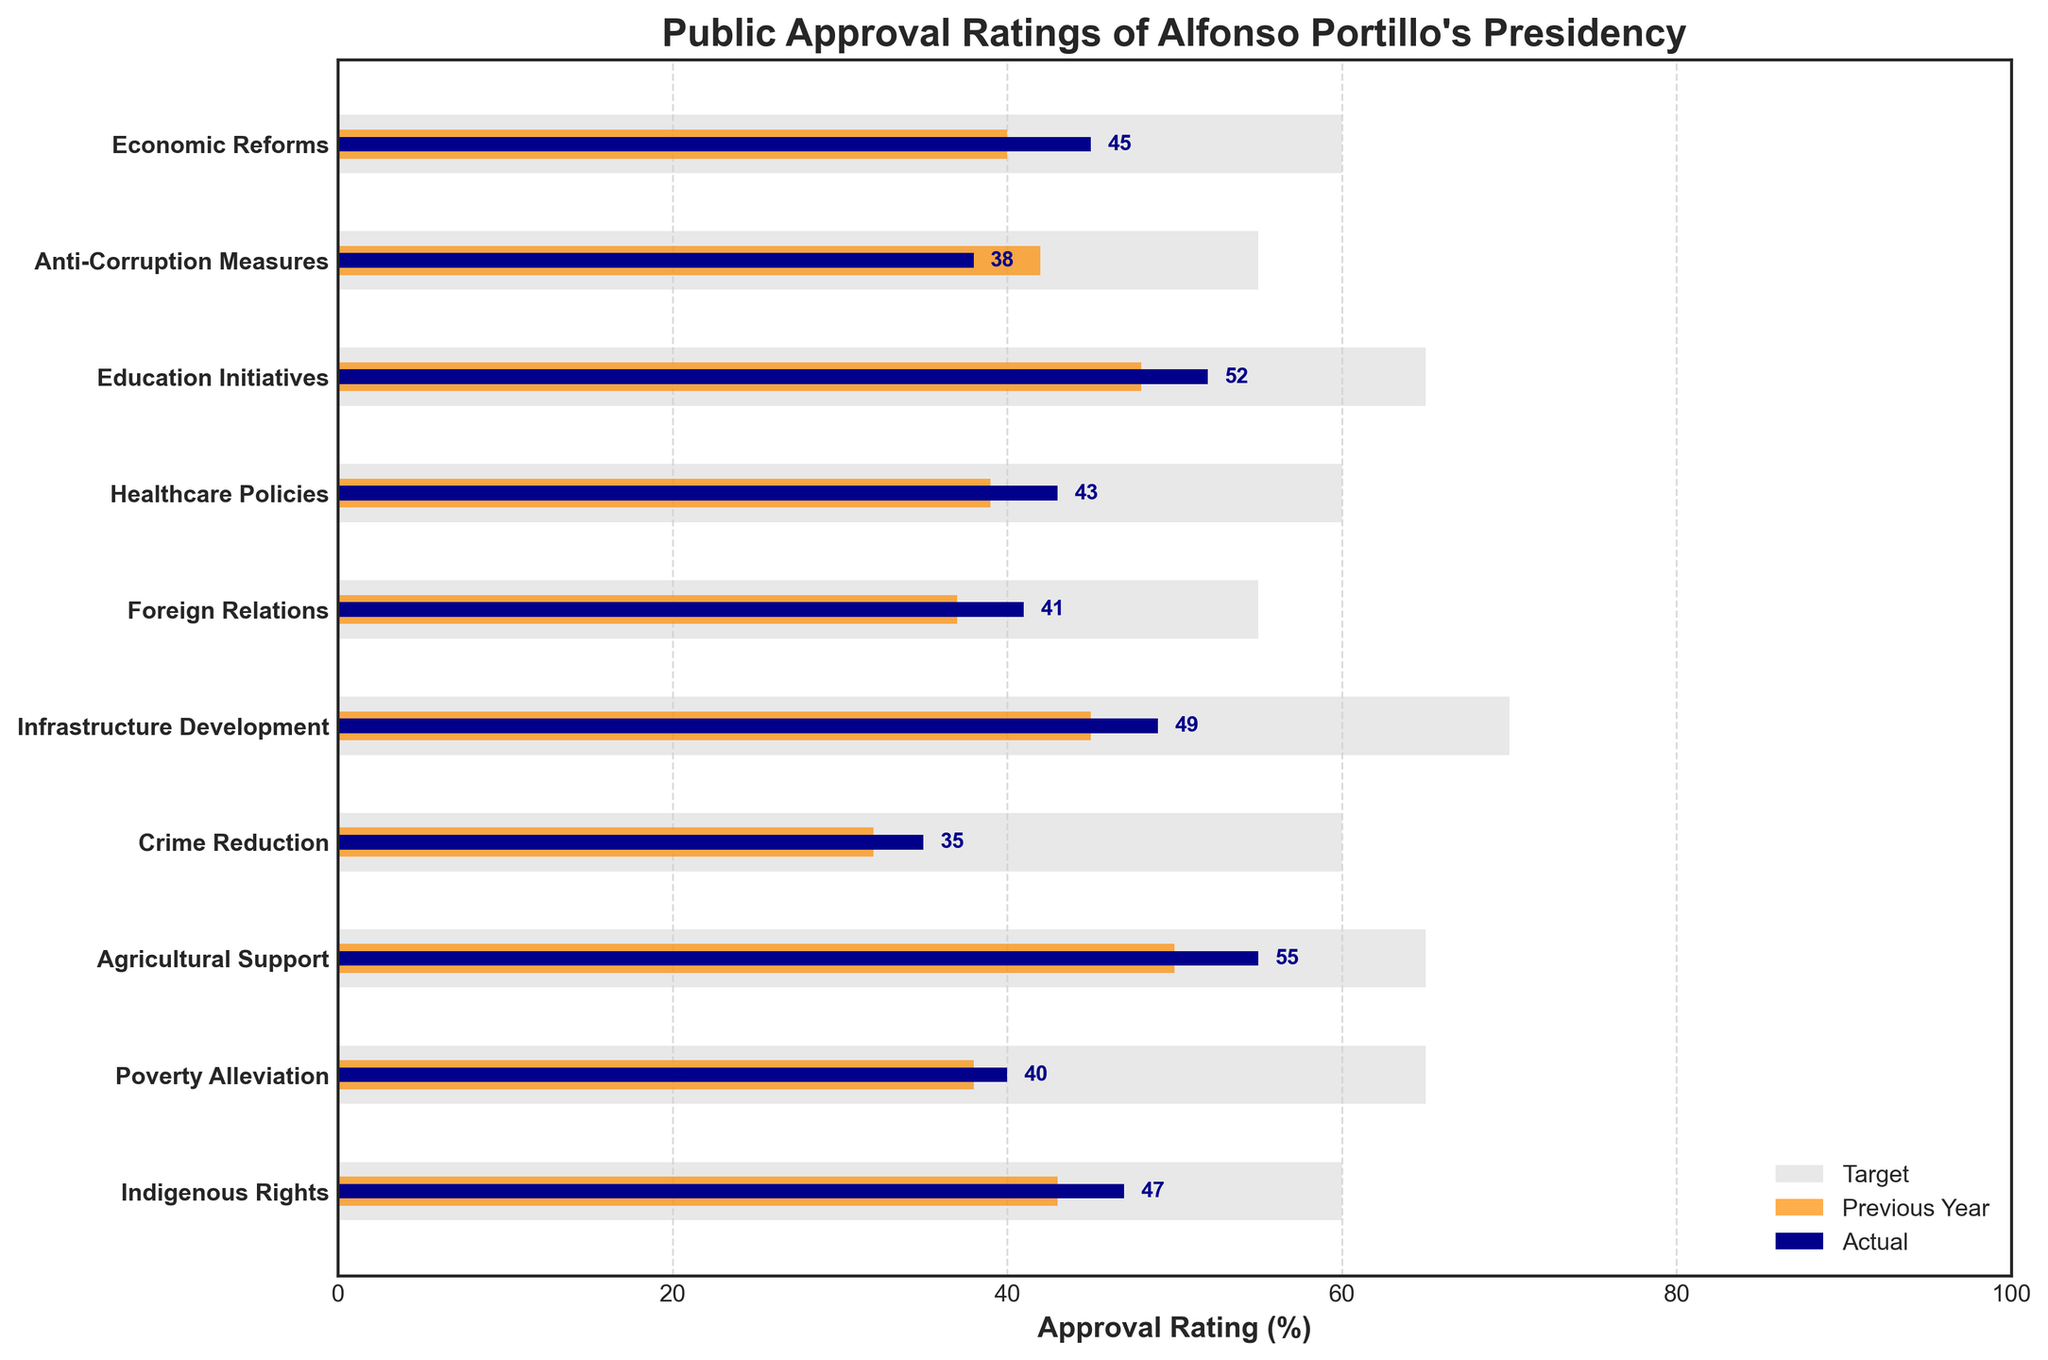What is the public approval rating for Economic Reforms? The Economic Reforms approval rating can be observed from the smallest blue bar for "Economic Reforms" on the y-axis, which corresponds to a value on the x-axis.
Answer: 45 What is the target approval rating for Anti-Corruption Measures? The target approval rating can be estimated from the longest grey bar for "Anti-Corruption Measures" on the y-axis, indicating the target value on the x-axis.
Answer: 55 How much did the approval rating for Education Initiatives increase compared to the previous year? You need to compare the height of the blue bar (current approval) with the dark orange bar (previous year approval) for "Education Initiatives". The blue bar is 52 and the dark orange bar is 48. Thus, the increase is 52 - 48.
Answer: 4 Which policy area has the highest actual approval rating? By comparing the lengths of the smallest blue bars for all policy areas, the one with the longest bar has the highest approval rating. In this case, "Agricultural Support" has the longest blue bar.
Answer: Agricultural Support What is the difference between the target approval and actual approval for Infrastructure Development? Find the lengths of both the grey and blue bars for "Infrastructure Development". The grey bar (target approval) is 70 and the blue bar (actual approval) is 49. The difference is 70 - 49.
Answer: 21 Which policy area shows a decrease in approval rating from the previous year? Compare the lengths of the blue and dark orange bars for each policy area. The policy area with the blue bar shorter than the dark orange bar has a decrease. "Anti-Corruption Measures" have a decrease (42 to 38).
Answer: Anti-Corruption Measures Considering all policy areas, what is the average target approval rating? Sum all the target approval ratings and divide by the number of policy areas. (60 + 55 + 65 + 60 + 55 + 70 + 60 + 65 + 65 + 60) / 10 = 61.5
Answer: 61.5 Which policy area had the smallest increase in approval rating compared to the previous year? Calculate the difference between current approval (blue bar) and previous year approval (dark orange bar) for each policy area, then find the smallest difference. For "Crime Reduction", the increase is minimal (32 to 35, an increase of 3).
Answer: Crime Reduction What is the median actual approval rating across all policy areas? List out the actual approval ratings (45, 38, 52, 43, 41, 49, 35, 55, 40, 47), then find the middle value. Arrange them: 35, 38, 40, 41, 43, 45, 47, 49, 52, 55. The median is (43 + 45) / 2.
Answer: 44 Which policy area has the lowest target approval rating? By comparing the lengths of the longest grey bars for all policy areas, the one with the shortest bar has the lowest target approval rating. This is "Anti-Corruption Measures".
Answer: Anti-Corruption Measures 